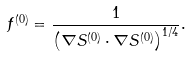<formula> <loc_0><loc_0><loc_500><loc_500>f ^ { ( 0 ) } = \frac { 1 } { \left ( \nabla S ^ { ( 0 ) } \cdot \nabla S ^ { ( 0 ) } \right ) ^ { 1 / 4 } } .</formula> 